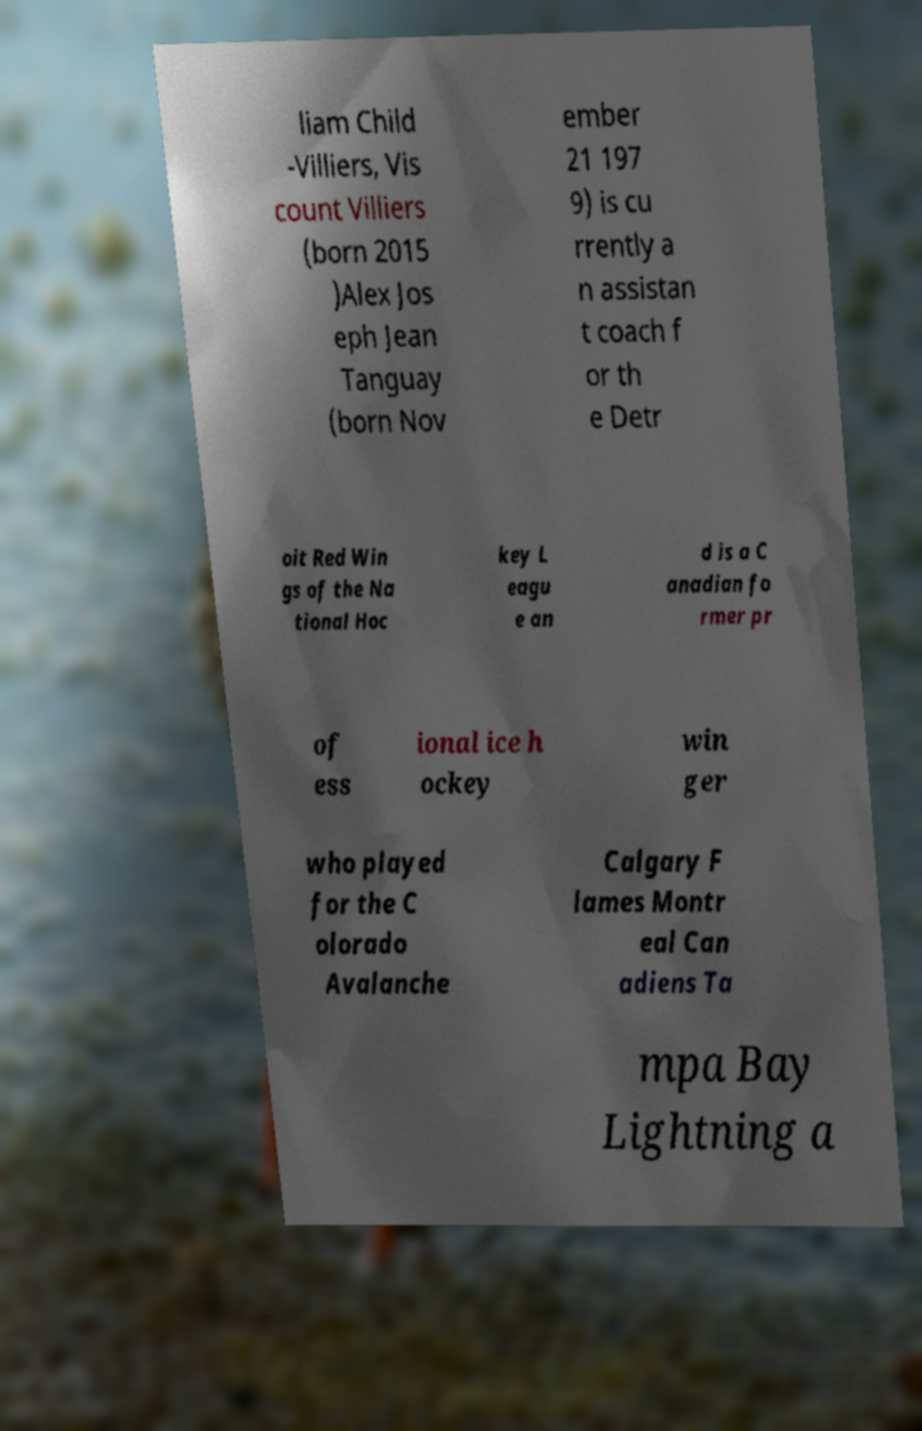I need the written content from this picture converted into text. Can you do that? liam Child -Villiers, Vis count Villiers (born 2015 )Alex Jos eph Jean Tanguay (born Nov ember 21 197 9) is cu rrently a n assistan t coach f or th e Detr oit Red Win gs of the Na tional Hoc key L eagu e an d is a C anadian fo rmer pr of ess ional ice h ockey win ger who played for the C olorado Avalanche Calgary F lames Montr eal Can adiens Ta mpa Bay Lightning a 